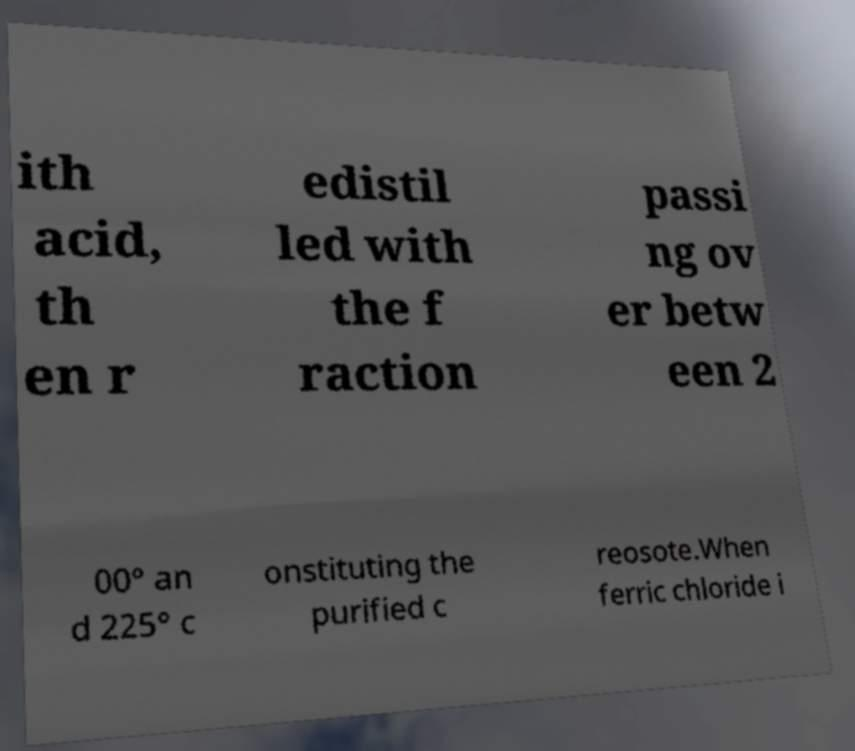Please read and relay the text visible in this image. What does it say? ith acid, th en r edistil led with the f raction passi ng ov er betw een 2 00° an d 225° c onstituting the purified c reosote.When ferric chloride i 